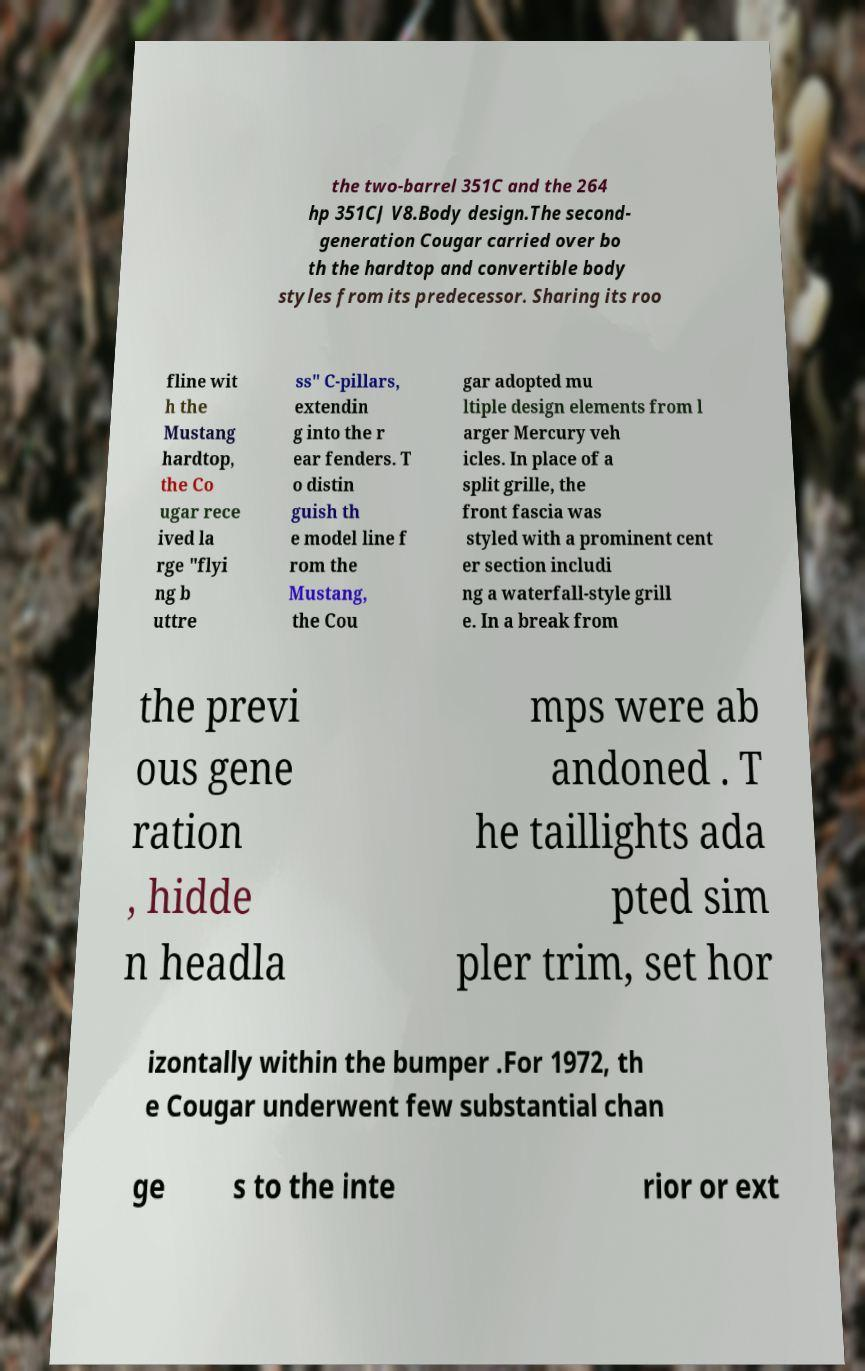There's text embedded in this image that I need extracted. Can you transcribe it verbatim? the two-barrel 351C and the 264 hp 351CJ V8.Body design.The second- generation Cougar carried over bo th the hardtop and convertible body styles from its predecessor. Sharing its roo fline wit h the Mustang hardtop, the Co ugar rece ived la rge "flyi ng b uttre ss" C-pillars, extendin g into the r ear fenders. T o distin guish th e model line f rom the Mustang, the Cou gar adopted mu ltiple design elements from l arger Mercury veh icles. In place of a split grille, the front fascia was styled with a prominent cent er section includi ng a waterfall-style grill e. In a break from the previ ous gene ration , hidde n headla mps were ab andoned . T he taillights ada pted sim pler trim, set hor izontally within the bumper .For 1972, th e Cougar underwent few substantial chan ge s to the inte rior or ext 